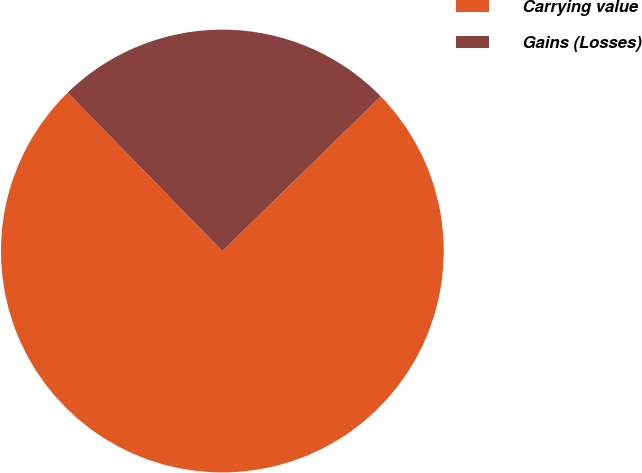<chart> <loc_0><loc_0><loc_500><loc_500><pie_chart><fcel>Carrying value<fcel>Gains (Losses)<nl><fcel>75.0%<fcel>25.0%<nl></chart> 